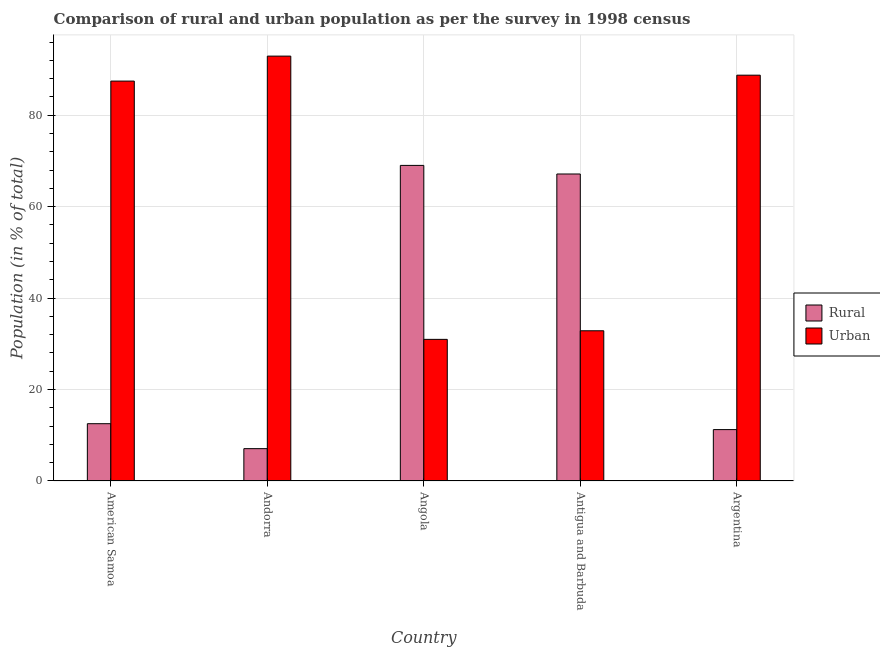How many different coloured bars are there?
Make the answer very short. 2. How many groups of bars are there?
Make the answer very short. 5. Are the number of bars per tick equal to the number of legend labels?
Your response must be concise. Yes. Are the number of bars on each tick of the X-axis equal?
Your answer should be very brief. Yes. How many bars are there on the 2nd tick from the right?
Your answer should be compact. 2. What is the label of the 4th group of bars from the left?
Provide a short and direct response. Antigua and Barbuda. What is the urban population in Antigua and Barbuda?
Your answer should be very brief. 32.85. Across all countries, what is the maximum rural population?
Give a very brief answer. 69.03. Across all countries, what is the minimum urban population?
Make the answer very short. 30.98. In which country was the urban population maximum?
Provide a short and direct response. Andorra. In which country was the urban population minimum?
Make the answer very short. Angola. What is the total rural population in the graph?
Offer a very short reply. 167.02. What is the difference between the rural population in American Samoa and that in Angola?
Provide a short and direct response. -56.49. What is the difference between the rural population in Argentina and the urban population in Andorra?
Your answer should be compact. -81.69. What is the average urban population per country?
Your answer should be compact. 66.6. What is the difference between the urban population and rural population in Andorra?
Make the answer very short. 85.85. What is the ratio of the rural population in American Samoa to that in Andorra?
Offer a terse response. 1.77. Is the difference between the rural population in Angola and Argentina greater than the difference between the urban population in Angola and Argentina?
Make the answer very short. Yes. What is the difference between the highest and the second highest rural population?
Keep it short and to the point. 1.88. What is the difference between the highest and the lowest urban population?
Offer a terse response. 61.95. Is the sum of the urban population in Andorra and Argentina greater than the maximum rural population across all countries?
Offer a terse response. Yes. What does the 1st bar from the left in Angola represents?
Provide a succinct answer. Rural. What does the 1st bar from the right in Angola represents?
Your answer should be compact. Urban. Are the values on the major ticks of Y-axis written in scientific E-notation?
Your answer should be compact. No. Does the graph contain grids?
Ensure brevity in your answer.  Yes. Where does the legend appear in the graph?
Provide a short and direct response. Center right. How are the legend labels stacked?
Keep it short and to the point. Vertical. What is the title of the graph?
Your response must be concise. Comparison of rural and urban population as per the survey in 1998 census. What is the label or title of the X-axis?
Provide a succinct answer. Country. What is the label or title of the Y-axis?
Offer a terse response. Population (in % of total). What is the Population (in % of total) in Rural in American Samoa?
Your answer should be very brief. 12.53. What is the Population (in % of total) in Urban in American Samoa?
Your response must be concise. 87.47. What is the Population (in % of total) of Rural in Andorra?
Make the answer very short. 7.07. What is the Population (in % of total) in Urban in Andorra?
Offer a very short reply. 92.93. What is the Population (in % of total) in Rural in Angola?
Provide a succinct answer. 69.03. What is the Population (in % of total) in Urban in Angola?
Your answer should be compact. 30.98. What is the Population (in % of total) of Rural in Antigua and Barbuda?
Make the answer very short. 67.14. What is the Population (in % of total) in Urban in Antigua and Barbuda?
Your response must be concise. 32.85. What is the Population (in % of total) in Rural in Argentina?
Your answer should be very brief. 11.24. What is the Population (in % of total) in Urban in Argentina?
Your answer should be very brief. 88.76. Across all countries, what is the maximum Population (in % of total) in Rural?
Offer a terse response. 69.03. Across all countries, what is the maximum Population (in % of total) of Urban?
Offer a very short reply. 92.93. Across all countries, what is the minimum Population (in % of total) in Rural?
Provide a short and direct response. 7.07. Across all countries, what is the minimum Population (in % of total) of Urban?
Keep it short and to the point. 30.98. What is the total Population (in % of total) in Rural in the graph?
Your answer should be compact. 167.02. What is the total Population (in % of total) in Urban in the graph?
Ensure brevity in your answer.  332.98. What is the difference between the Population (in % of total) of Rural in American Samoa and that in Andorra?
Provide a short and direct response. 5.46. What is the difference between the Population (in % of total) in Urban in American Samoa and that in Andorra?
Provide a short and direct response. -5.46. What is the difference between the Population (in % of total) of Rural in American Samoa and that in Angola?
Make the answer very short. -56.49. What is the difference between the Population (in % of total) in Urban in American Samoa and that in Angola?
Offer a terse response. 56.49. What is the difference between the Population (in % of total) of Rural in American Samoa and that in Antigua and Barbuda?
Provide a succinct answer. -54.61. What is the difference between the Population (in % of total) of Urban in American Samoa and that in Antigua and Barbuda?
Give a very brief answer. 54.61. What is the difference between the Population (in % of total) of Rural in American Samoa and that in Argentina?
Make the answer very short. 1.29. What is the difference between the Population (in % of total) of Urban in American Samoa and that in Argentina?
Your answer should be very brief. -1.29. What is the difference between the Population (in % of total) of Rural in Andorra and that in Angola?
Offer a terse response. -61.95. What is the difference between the Population (in % of total) in Urban in Andorra and that in Angola?
Give a very brief answer. 61.95. What is the difference between the Population (in % of total) of Rural in Andorra and that in Antigua and Barbuda?
Offer a very short reply. -60.07. What is the difference between the Population (in % of total) in Urban in Andorra and that in Antigua and Barbuda?
Your answer should be very brief. 60.07. What is the difference between the Population (in % of total) of Rural in Andorra and that in Argentina?
Provide a succinct answer. -4.17. What is the difference between the Population (in % of total) in Urban in Andorra and that in Argentina?
Offer a very short reply. 4.17. What is the difference between the Population (in % of total) in Rural in Angola and that in Antigua and Barbuda?
Your response must be concise. 1.88. What is the difference between the Population (in % of total) in Urban in Angola and that in Antigua and Barbuda?
Your answer should be very brief. -1.88. What is the difference between the Population (in % of total) of Rural in Angola and that in Argentina?
Provide a succinct answer. 57.78. What is the difference between the Population (in % of total) in Urban in Angola and that in Argentina?
Make the answer very short. -57.78. What is the difference between the Population (in % of total) in Rural in Antigua and Barbuda and that in Argentina?
Keep it short and to the point. 55.9. What is the difference between the Population (in % of total) of Urban in Antigua and Barbuda and that in Argentina?
Make the answer very short. -55.9. What is the difference between the Population (in % of total) in Rural in American Samoa and the Population (in % of total) in Urban in Andorra?
Your answer should be compact. -80.39. What is the difference between the Population (in % of total) of Rural in American Samoa and the Population (in % of total) of Urban in Angola?
Keep it short and to the point. -18.44. What is the difference between the Population (in % of total) of Rural in American Samoa and the Population (in % of total) of Urban in Antigua and Barbuda?
Provide a short and direct response. -20.32. What is the difference between the Population (in % of total) of Rural in American Samoa and the Population (in % of total) of Urban in Argentina?
Offer a very short reply. -76.23. What is the difference between the Population (in % of total) in Rural in Andorra and the Population (in % of total) in Urban in Angola?
Ensure brevity in your answer.  -23.9. What is the difference between the Population (in % of total) of Rural in Andorra and the Population (in % of total) of Urban in Antigua and Barbuda?
Give a very brief answer. -25.78. What is the difference between the Population (in % of total) in Rural in Andorra and the Population (in % of total) in Urban in Argentina?
Keep it short and to the point. -81.69. What is the difference between the Population (in % of total) of Rural in Angola and the Population (in % of total) of Urban in Antigua and Barbuda?
Give a very brief answer. 36.17. What is the difference between the Population (in % of total) in Rural in Angola and the Population (in % of total) in Urban in Argentina?
Your answer should be compact. -19.73. What is the difference between the Population (in % of total) in Rural in Antigua and Barbuda and the Population (in % of total) in Urban in Argentina?
Keep it short and to the point. -21.61. What is the average Population (in % of total) in Rural per country?
Your response must be concise. 33.4. What is the average Population (in % of total) in Urban per country?
Offer a very short reply. 66.6. What is the difference between the Population (in % of total) of Rural and Population (in % of total) of Urban in American Samoa?
Your answer should be compact. -74.93. What is the difference between the Population (in % of total) in Rural and Population (in % of total) in Urban in Andorra?
Give a very brief answer. -85.85. What is the difference between the Population (in % of total) of Rural and Population (in % of total) of Urban in Angola?
Offer a very short reply. 38.05. What is the difference between the Population (in % of total) in Rural and Population (in % of total) in Urban in Antigua and Barbuda?
Make the answer very short. 34.29. What is the difference between the Population (in % of total) of Rural and Population (in % of total) of Urban in Argentina?
Provide a succinct answer. -77.52. What is the ratio of the Population (in % of total) of Rural in American Samoa to that in Andorra?
Offer a terse response. 1.77. What is the ratio of the Population (in % of total) of Urban in American Samoa to that in Andorra?
Keep it short and to the point. 0.94. What is the ratio of the Population (in % of total) of Rural in American Samoa to that in Angola?
Ensure brevity in your answer.  0.18. What is the ratio of the Population (in % of total) in Urban in American Samoa to that in Angola?
Offer a terse response. 2.82. What is the ratio of the Population (in % of total) in Rural in American Samoa to that in Antigua and Barbuda?
Offer a very short reply. 0.19. What is the ratio of the Population (in % of total) in Urban in American Samoa to that in Antigua and Barbuda?
Make the answer very short. 2.66. What is the ratio of the Population (in % of total) of Rural in American Samoa to that in Argentina?
Provide a short and direct response. 1.11. What is the ratio of the Population (in % of total) of Urban in American Samoa to that in Argentina?
Ensure brevity in your answer.  0.99. What is the ratio of the Population (in % of total) of Rural in Andorra to that in Angola?
Offer a terse response. 0.1. What is the ratio of the Population (in % of total) of Urban in Andorra to that in Angola?
Keep it short and to the point. 3. What is the ratio of the Population (in % of total) of Rural in Andorra to that in Antigua and Barbuda?
Provide a short and direct response. 0.11. What is the ratio of the Population (in % of total) in Urban in Andorra to that in Antigua and Barbuda?
Your answer should be very brief. 2.83. What is the ratio of the Population (in % of total) in Rural in Andorra to that in Argentina?
Ensure brevity in your answer.  0.63. What is the ratio of the Population (in % of total) in Urban in Andorra to that in Argentina?
Give a very brief answer. 1.05. What is the ratio of the Population (in % of total) in Rural in Angola to that in Antigua and Barbuda?
Keep it short and to the point. 1.03. What is the ratio of the Population (in % of total) of Urban in Angola to that in Antigua and Barbuda?
Give a very brief answer. 0.94. What is the ratio of the Population (in % of total) in Rural in Angola to that in Argentina?
Provide a short and direct response. 6.14. What is the ratio of the Population (in % of total) in Urban in Angola to that in Argentina?
Provide a short and direct response. 0.35. What is the ratio of the Population (in % of total) in Rural in Antigua and Barbuda to that in Argentina?
Your answer should be compact. 5.97. What is the ratio of the Population (in % of total) in Urban in Antigua and Barbuda to that in Argentina?
Your answer should be very brief. 0.37. What is the difference between the highest and the second highest Population (in % of total) of Rural?
Make the answer very short. 1.88. What is the difference between the highest and the second highest Population (in % of total) of Urban?
Make the answer very short. 4.17. What is the difference between the highest and the lowest Population (in % of total) in Rural?
Your answer should be very brief. 61.95. What is the difference between the highest and the lowest Population (in % of total) in Urban?
Make the answer very short. 61.95. 